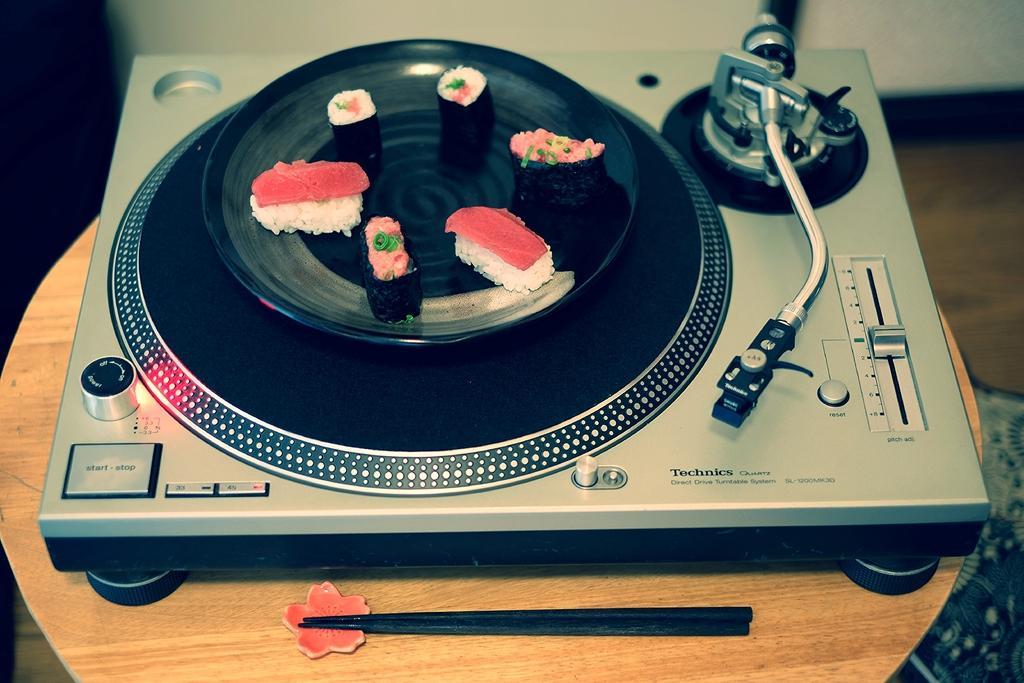How would you summarize this image in a sentence or two? In this picture we can see portable Gamma-phone is placed on the wooden table top. On the top we can see a black color plate in which some chocolate pastry is seen. 